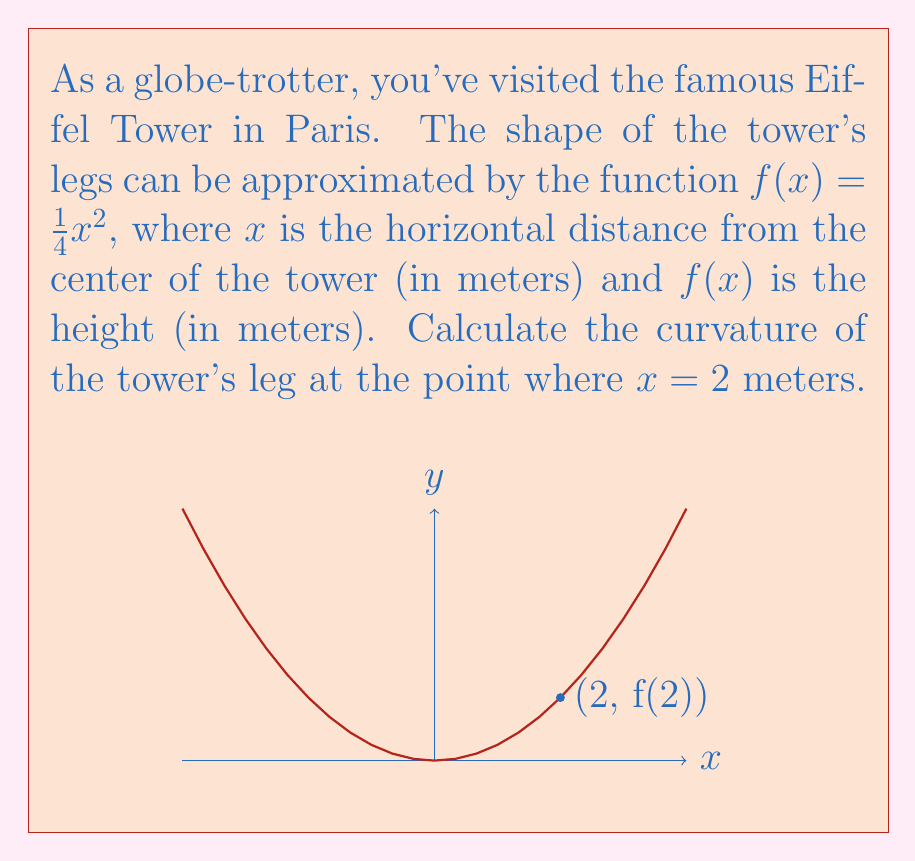Give your solution to this math problem. To calculate the curvature, we'll use the formula for the curvature of a function $y = f(x)$:

$$\kappa = \frac{|f''(x)|}{(1 + [f'(x)]^2)^{3/2}}$$

Step 1: Find $f'(x)$ and $f''(x)$
$f(x) = \frac{1}{4}x^2$
$f'(x) = \frac{1}{2}x$
$f''(x) = \frac{1}{2}$

Step 2: Evaluate $f'(x)$ at $x = 2$
$f'(2) = \frac{1}{2}(2) = 1$

Step 3: Substitute values into the curvature formula
$$\kappa = \frac{|\frac{1}{2}|}{(1 + [1]^2)^{3/2}}$$

Step 4: Simplify
$$\kappa = \frac{0.5}{(1 + 1)^{3/2}} = \frac{0.5}{2^{3/2}} = \frac{0.5}{2\sqrt{2}}$$

Step 5: Simplify further
$$\kappa = \frac{1}{4\sqrt{2}} \approx 0.1768 \text{ m}^{-1}$$
Answer: $\frac{1}{4\sqrt{2}}$ m$^{-1}$ 